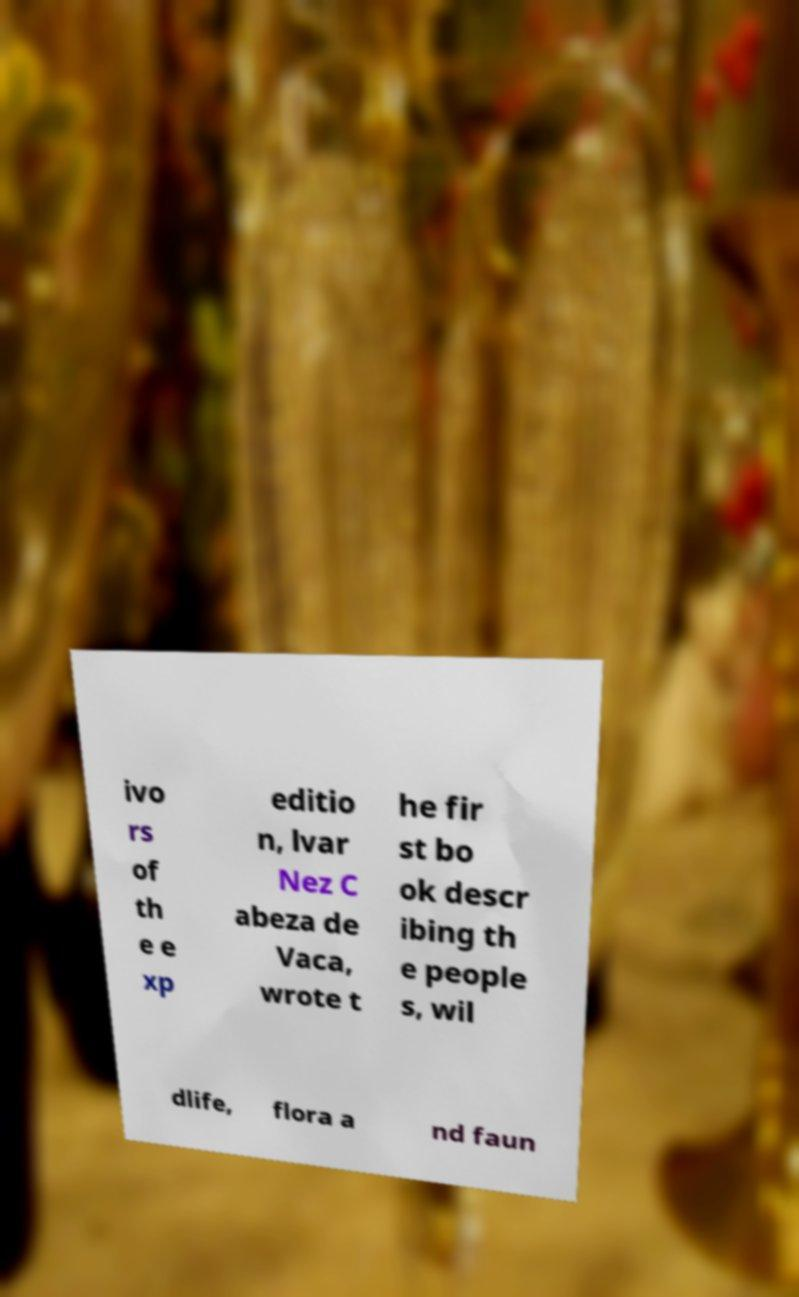There's text embedded in this image that I need extracted. Can you transcribe it verbatim? ivo rs of th e e xp editio n, lvar Nez C abeza de Vaca, wrote t he fir st bo ok descr ibing th e people s, wil dlife, flora a nd faun 